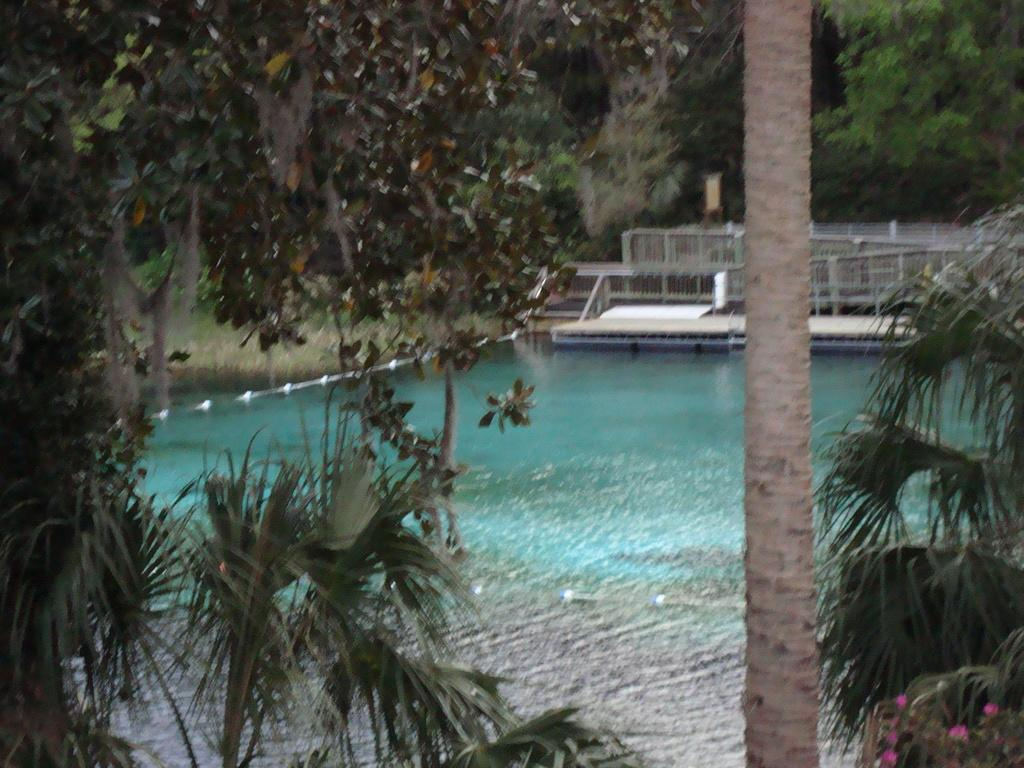What is the primary element visible in the image? There is water in the image. What structure can be seen in the image? There is a platform in the image. What type of barrier is present in the image? There is a fence in the image. What type of plants are visible in the image? There are flowers in the image. What else can be seen in the image besides the water, platform, fence, and flowers? There are objects in the image. What can be seen in the background of the image? There are trees in the background of the image. What flavor of hen can be seen in the image? There is no hen present in the image. What type of chin is visible on the flowers in the image? There are no chins visible in the image, as flowers do not have chins. 